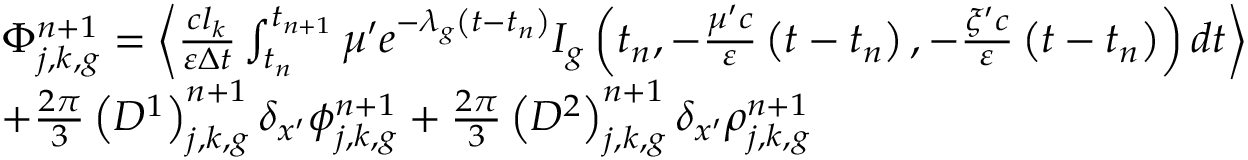<formula> <loc_0><loc_0><loc_500><loc_500>\begin{array} { l } { { \Phi _ { j , k , g } ^ { n + 1 } = \left \langle \frac { c l _ { k } } { \varepsilon \Delta t } \int _ { t _ { n } } ^ { t _ { n + 1 } } \mu ^ { \prime } e ^ { - \lambda _ { g } \left ( t - t _ { n } \right ) } I _ { g } \left ( t _ { n } , - \frac { \mu ^ { \prime } c } { \varepsilon } \left ( t - t _ { n } \right ) , - \frac { \xi ^ { \prime } c } { \varepsilon } \left ( t - t _ { n } \right ) \right ) d t \right \rangle } } \\ { { + \frac { 2 \pi } { 3 } \left ( D ^ { 1 } \right ) _ { j , k , g } ^ { n + 1 } \delta _ { x ^ { \prime } } \phi _ { j , k , g } ^ { n + 1 } + \frac { 2 \pi } { 3 } \left ( D ^ { 2 } \right ) _ { j , k , g } ^ { n + 1 } \delta _ { x ^ { \prime } } \rho _ { j , k , g } ^ { n + 1 } } } \end{array}</formula> 